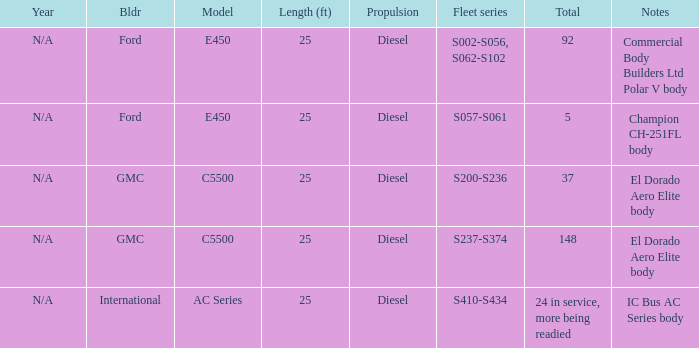What are the notes for Ford when the total is 5? Champion CH-251FL body. 